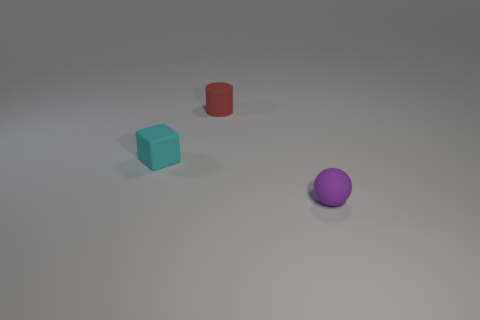Add 3 tiny red rubber things. How many objects exist? 6 Subtract all cylinders. How many objects are left? 2 Add 2 purple balls. How many purple balls exist? 3 Subtract 0 blue balls. How many objects are left? 3 Subtract all cylinders. Subtract all red things. How many objects are left? 1 Add 2 spheres. How many spheres are left? 3 